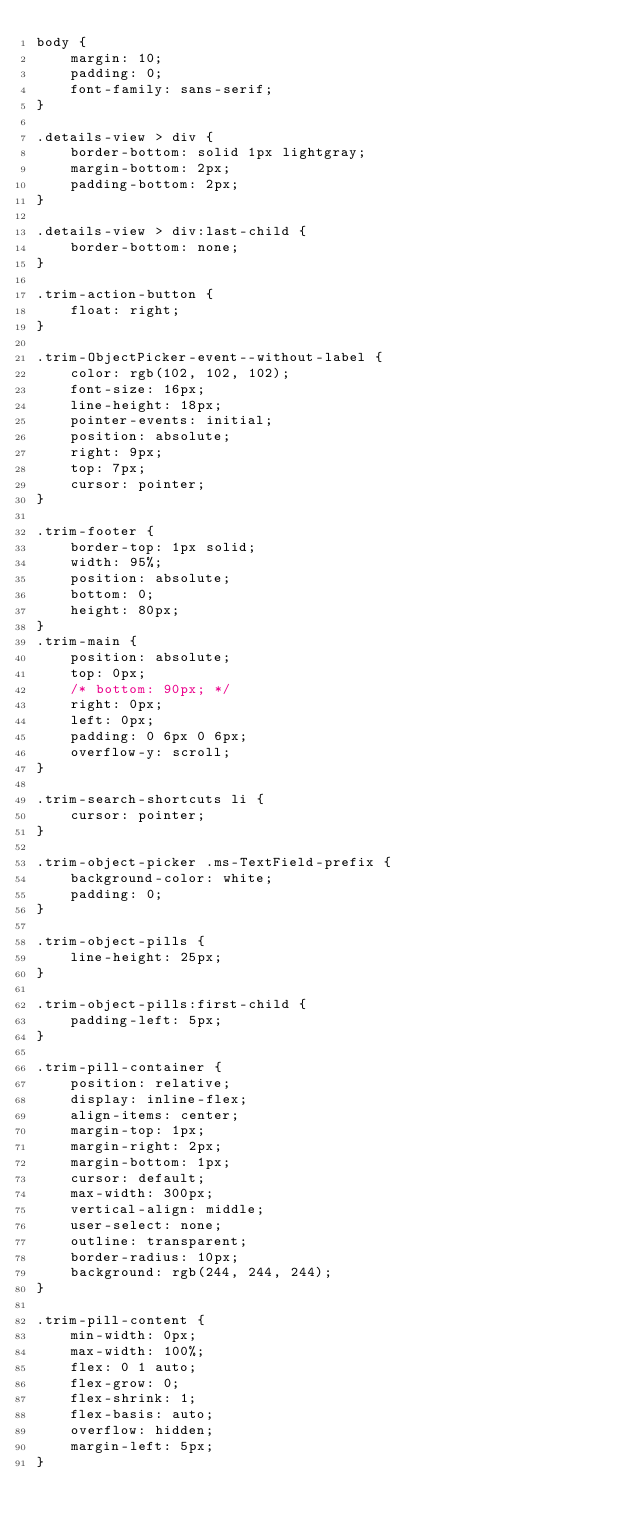Convert code to text. <code><loc_0><loc_0><loc_500><loc_500><_CSS_>body {
	margin: 10;
	padding: 0;
	font-family: sans-serif;
}

.details-view > div {
	border-bottom: solid 1px lightgray;
	margin-bottom: 2px;
	padding-bottom: 2px;
}

.details-view > div:last-child {
	border-bottom: none;
}

.trim-action-button {
	float: right;
}

.trim-ObjectPicker-event--without-label {
	color: rgb(102, 102, 102);
	font-size: 16px;
	line-height: 18px;
	pointer-events: initial;
	position: absolute;
	right: 9px;
	top: 7px;
	cursor: pointer;
}

.trim-footer {
	border-top: 1px solid;
	width: 95%;
	position: absolute;
	bottom: 0;
	height: 80px;
}
.trim-main {
	position: absolute;
	top: 0px;
	/* bottom: 90px; */
	right: 0px;
	left: 0px;
	padding: 0 6px 0 6px;
	overflow-y: scroll;
}

.trim-search-shortcuts li {
	cursor: pointer;
}

.trim-object-picker .ms-TextField-prefix {
	background-color: white;
	padding: 0;
}

.trim-object-pills {
	line-height: 25px;
}

.trim-object-pills:first-child {
	padding-left: 5px;
}

.trim-pill-container {
	position: relative;
	display: inline-flex;
	align-items: center;
	margin-top: 1px;
	margin-right: 2px;
	margin-bottom: 1px;
	cursor: default;
	max-width: 300px;
	vertical-align: middle;
	user-select: none;
	outline: transparent;
	border-radius: 10px;
	background: rgb(244, 244, 244);
}

.trim-pill-content {
	min-width: 0px;
	max-width: 100%;
	flex: 0 1 auto;
	flex-grow: 0;
	flex-shrink: 1;
	flex-basis: auto;
	overflow: hidden;
	margin-left: 5px;
}</code> 